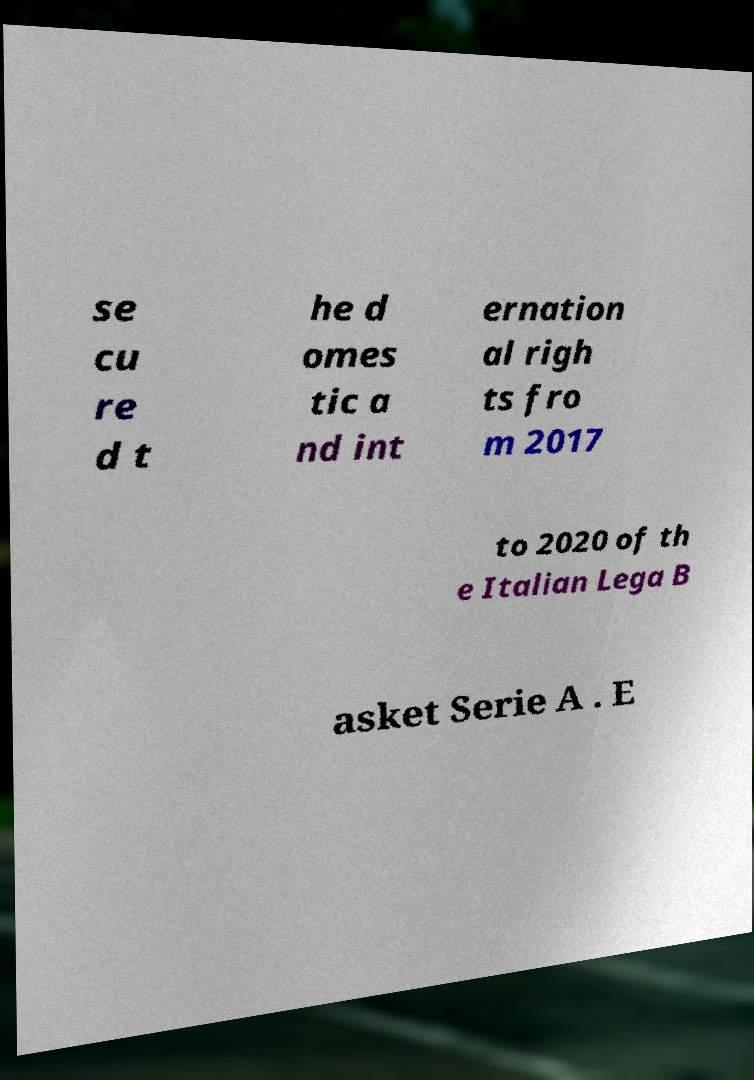There's text embedded in this image that I need extracted. Can you transcribe it verbatim? se cu re d t he d omes tic a nd int ernation al righ ts fro m 2017 to 2020 of th e Italian Lega B asket Serie A . E 